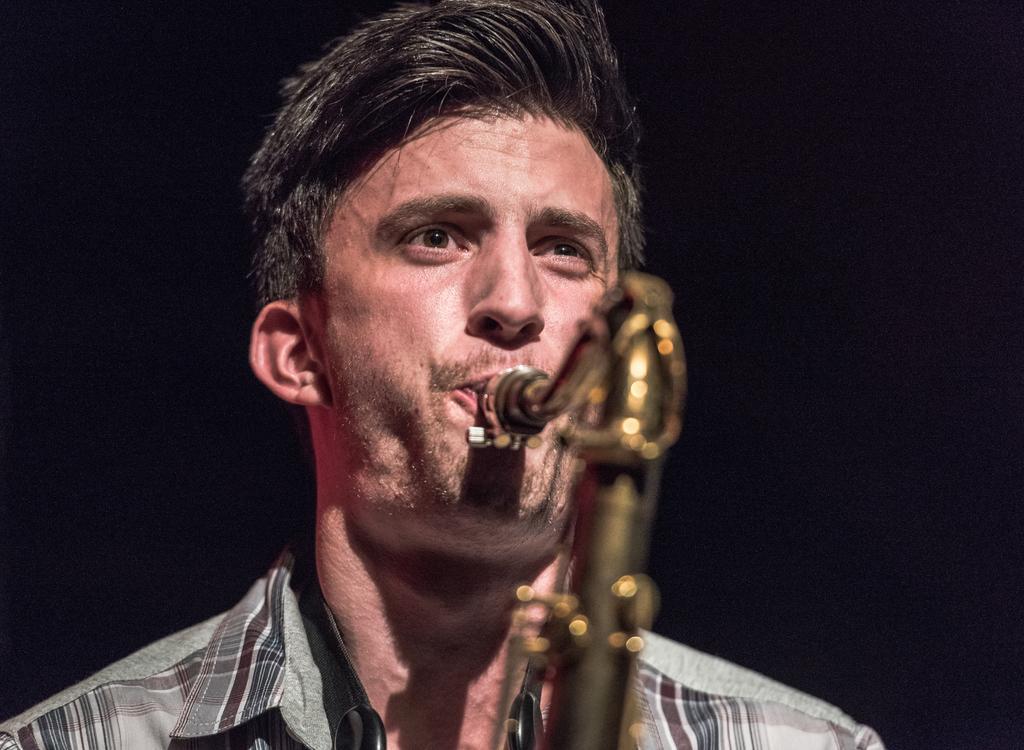How would you summarize this image in a sentence or two? A man is playing a musical instrument by his mouth. In the background the image is dark. 